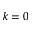<formula> <loc_0><loc_0><loc_500><loc_500>k = 0</formula> 